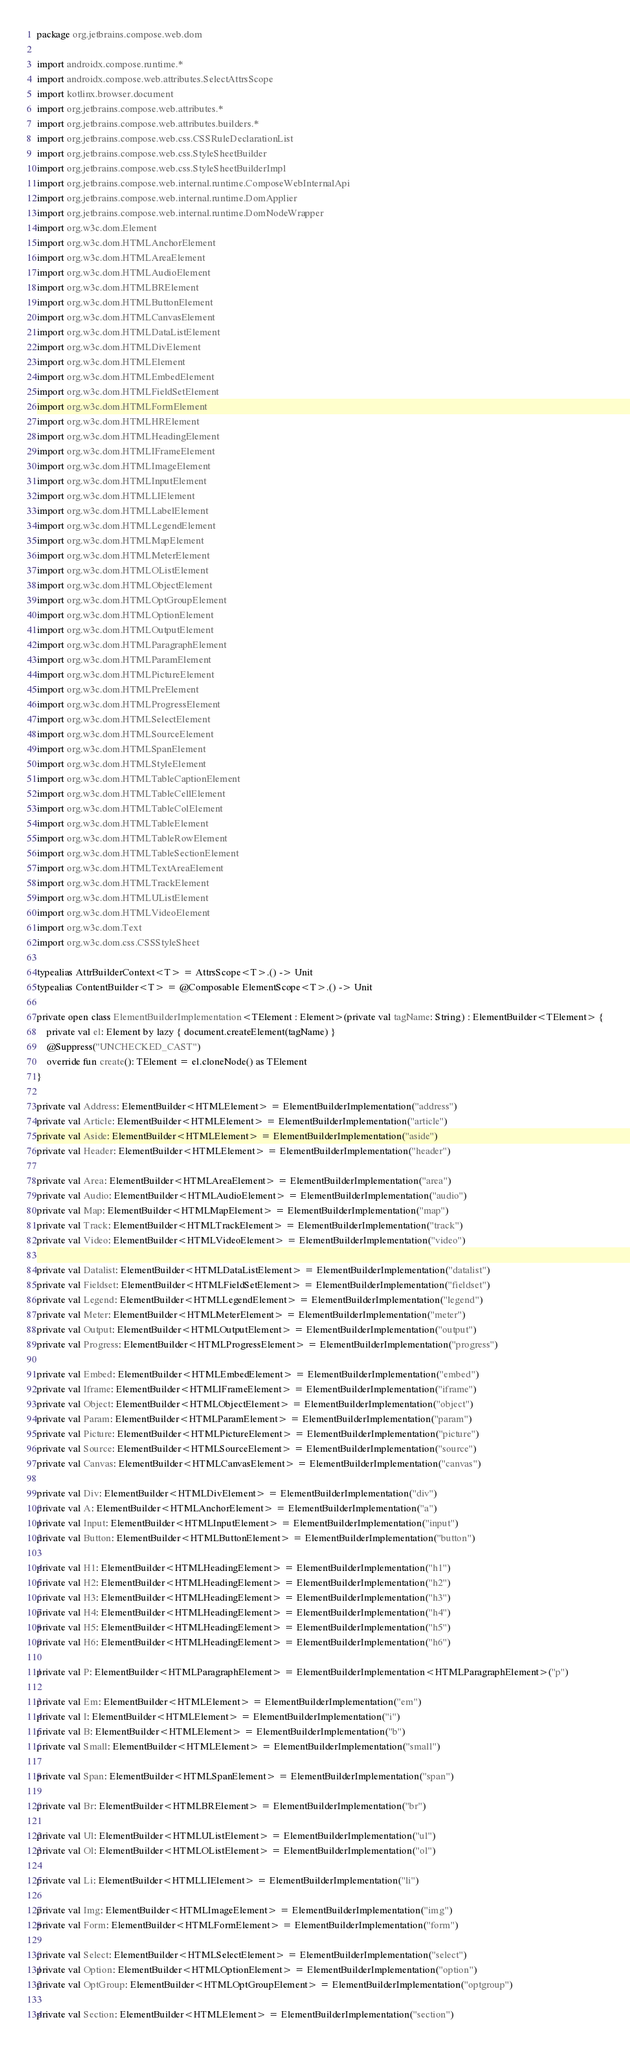Convert code to text. <code><loc_0><loc_0><loc_500><loc_500><_Kotlin_>package org.jetbrains.compose.web.dom

import androidx.compose.runtime.*
import androidx.compose.web.attributes.SelectAttrsScope
import kotlinx.browser.document
import org.jetbrains.compose.web.attributes.*
import org.jetbrains.compose.web.attributes.builders.*
import org.jetbrains.compose.web.css.CSSRuleDeclarationList
import org.jetbrains.compose.web.css.StyleSheetBuilder
import org.jetbrains.compose.web.css.StyleSheetBuilderImpl
import org.jetbrains.compose.web.internal.runtime.ComposeWebInternalApi
import org.jetbrains.compose.web.internal.runtime.DomApplier
import org.jetbrains.compose.web.internal.runtime.DomNodeWrapper
import org.w3c.dom.Element
import org.w3c.dom.HTMLAnchorElement
import org.w3c.dom.HTMLAreaElement
import org.w3c.dom.HTMLAudioElement
import org.w3c.dom.HTMLBRElement
import org.w3c.dom.HTMLButtonElement
import org.w3c.dom.HTMLCanvasElement
import org.w3c.dom.HTMLDataListElement
import org.w3c.dom.HTMLDivElement
import org.w3c.dom.HTMLElement
import org.w3c.dom.HTMLEmbedElement
import org.w3c.dom.HTMLFieldSetElement
import org.w3c.dom.HTMLFormElement
import org.w3c.dom.HTMLHRElement
import org.w3c.dom.HTMLHeadingElement
import org.w3c.dom.HTMLIFrameElement
import org.w3c.dom.HTMLImageElement
import org.w3c.dom.HTMLInputElement
import org.w3c.dom.HTMLLIElement
import org.w3c.dom.HTMLLabelElement
import org.w3c.dom.HTMLLegendElement
import org.w3c.dom.HTMLMapElement
import org.w3c.dom.HTMLMeterElement
import org.w3c.dom.HTMLOListElement
import org.w3c.dom.HTMLObjectElement
import org.w3c.dom.HTMLOptGroupElement
import org.w3c.dom.HTMLOptionElement
import org.w3c.dom.HTMLOutputElement
import org.w3c.dom.HTMLParagraphElement
import org.w3c.dom.HTMLParamElement
import org.w3c.dom.HTMLPictureElement
import org.w3c.dom.HTMLPreElement
import org.w3c.dom.HTMLProgressElement
import org.w3c.dom.HTMLSelectElement
import org.w3c.dom.HTMLSourceElement
import org.w3c.dom.HTMLSpanElement
import org.w3c.dom.HTMLStyleElement
import org.w3c.dom.HTMLTableCaptionElement
import org.w3c.dom.HTMLTableCellElement
import org.w3c.dom.HTMLTableColElement
import org.w3c.dom.HTMLTableElement
import org.w3c.dom.HTMLTableRowElement
import org.w3c.dom.HTMLTableSectionElement
import org.w3c.dom.HTMLTextAreaElement
import org.w3c.dom.HTMLTrackElement
import org.w3c.dom.HTMLUListElement
import org.w3c.dom.HTMLVideoElement
import org.w3c.dom.Text
import org.w3c.dom.css.CSSStyleSheet

typealias AttrBuilderContext<T> = AttrsScope<T>.() -> Unit
typealias ContentBuilder<T> = @Composable ElementScope<T>.() -> Unit

private open class ElementBuilderImplementation<TElement : Element>(private val tagName: String) : ElementBuilder<TElement> {
    private val el: Element by lazy { document.createElement(tagName) }
    @Suppress("UNCHECKED_CAST")
    override fun create(): TElement = el.cloneNode() as TElement
}

private val Address: ElementBuilder<HTMLElement> = ElementBuilderImplementation("address")
private val Article: ElementBuilder<HTMLElement> = ElementBuilderImplementation("article")
private val Aside: ElementBuilder<HTMLElement> = ElementBuilderImplementation("aside")
private val Header: ElementBuilder<HTMLElement> = ElementBuilderImplementation("header")

private val Area: ElementBuilder<HTMLAreaElement> = ElementBuilderImplementation("area")
private val Audio: ElementBuilder<HTMLAudioElement> = ElementBuilderImplementation("audio")
private val Map: ElementBuilder<HTMLMapElement> = ElementBuilderImplementation("map")
private val Track: ElementBuilder<HTMLTrackElement> = ElementBuilderImplementation("track")
private val Video: ElementBuilder<HTMLVideoElement> = ElementBuilderImplementation("video")

private val Datalist: ElementBuilder<HTMLDataListElement> = ElementBuilderImplementation("datalist")
private val Fieldset: ElementBuilder<HTMLFieldSetElement> = ElementBuilderImplementation("fieldset")
private val Legend: ElementBuilder<HTMLLegendElement> = ElementBuilderImplementation("legend")
private val Meter: ElementBuilder<HTMLMeterElement> = ElementBuilderImplementation("meter")
private val Output: ElementBuilder<HTMLOutputElement> = ElementBuilderImplementation("output")
private val Progress: ElementBuilder<HTMLProgressElement> = ElementBuilderImplementation("progress")

private val Embed: ElementBuilder<HTMLEmbedElement> = ElementBuilderImplementation("embed")
private val Iframe: ElementBuilder<HTMLIFrameElement> = ElementBuilderImplementation("iframe")
private val Object: ElementBuilder<HTMLObjectElement> = ElementBuilderImplementation("object")
private val Param: ElementBuilder<HTMLParamElement> = ElementBuilderImplementation("param")
private val Picture: ElementBuilder<HTMLPictureElement> = ElementBuilderImplementation("picture")
private val Source: ElementBuilder<HTMLSourceElement> = ElementBuilderImplementation("source")
private val Canvas: ElementBuilder<HTMLCanvasElement> = ElementBuilderImplementation("canvas")

private val Div: ElementBuilder<HTMLDivElement> = ElementBuilderImplementation("div")
private val A: ElementBuilder<HTMLAnchorElement> = ElementBuilderImplementation("a")
private val Input: ElementBuilder<HTMLInputElement> = ElementBuilderImplementation("input")
private val Button: ElementBuilder<HTMLButtonElement> = ElementBuilderImplementation("button")

private val H1: ElementBuilder<HTMLHeadingElement> = ElementBuilderImplementation("h1")
private val H2: ElementBuilder<HTMLHeadingElement> = ElementBuilderImplementation("h2")
private val H3: ElementBuilder<HTMLHeadingElement> = ElementBuilderImplementation("h3")
private val H4: ElementBuilder<HTMLHeadingElement> = ElementBuilderImplementation("h4")
private val H5: ElementBuilder<HTMLHeadingElement> = ElementBuilderImplementation("h5")
private val H6: ElementBuilder<HTMLHeadingElement> = ElementBuilderImplementation("h6")

private val P: ElementBuilder<HTMLParagraphElement> = ElementBuilderImplementation<HTMLParagraphElement>("p")

private val Em: ElementBuilder<HTMLElement> = ElementBuilderImplementation("em")
private val I: ElementBuilder<HTMLElement> = ElementBuilderImplementation("i")
private val B: ElementBuilder<HTMLElement> = ElementBuilderImplementation("b")
private val Small: ElementBuilder<HTMLElement> = ElementBuilderImplementation("small")

private val Span: ElementBuilder<HTMLSpanElement> = ElementBuilderImplementation("span")

private val Br: ElementBuilder<HTMLBRElement> = ElementBuilderImplementation("br")

private val Ul: ElementBuilder<HTMLUListElement> = ElementBuilderImplementation("ul")
private val Ol: ElementBuilder<HTMLOListElement> = ElementBuilderImplementation("ol")

private val Li: ElementBuilder<HTMLLIElement> = ElementBuilderImplementation("li")

private val Img: ElementBuilder<HTMLImageElement> = ElementBuilderImplementation("img")
private val Form: ElementBuilder<HTMLFormElement> = ElementBuilderImplementation("form")

private val Select: ElementBuilder<HTMLSelectElement> = ElementBuilderImplementation("select")
private val Option: ElementBuilder<HTMLOptionElement> = ElementBuilderImplementation("option")
private val OptGroup: ElementBuilder<HTMLOptGroupElement> = ElementBuilderImplementation("optgroup")

private val Section: ElementBuilder<HTMLElement> = ElementBuilderImplementation("section")</code> 